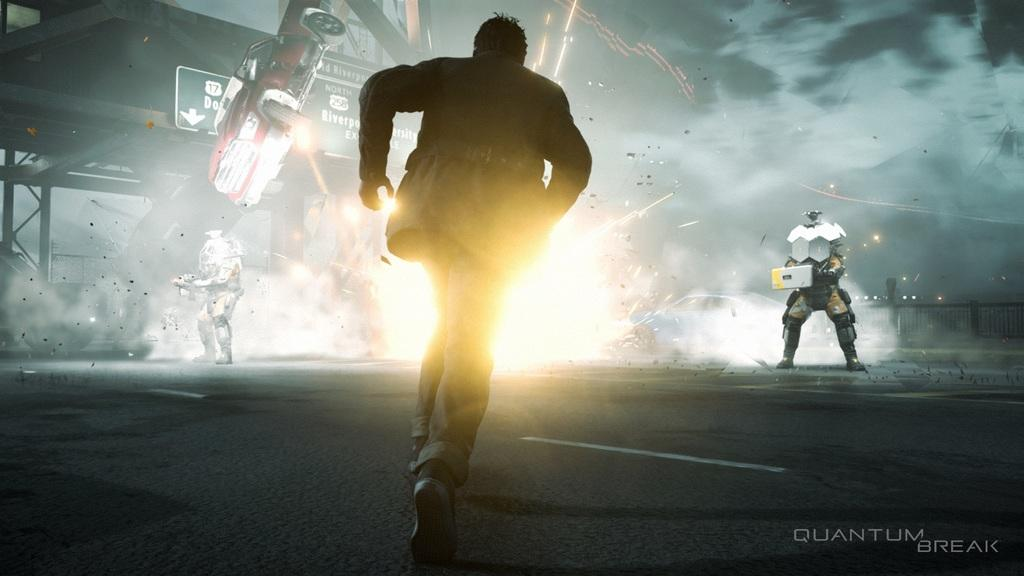What is the man in the image doing? The man is running in the image. Can you describe the appearance of the two people in the image? The two people are wearing costumes in the image. What type of vehicle is present in the image? There is a car in the image. What is the source of the fire in the image? The information provided does not specify the source of the fire. What is the large sign in the image called? There is a hoarding in the image. What type of barrier is located at the right back of the image? There is a fence at the right back of the image. What type of statement is being made by the ghost in the image? There is no ghost present in the image. What type of building is visible in the image? The information provided does not mention any buildings in the image. 